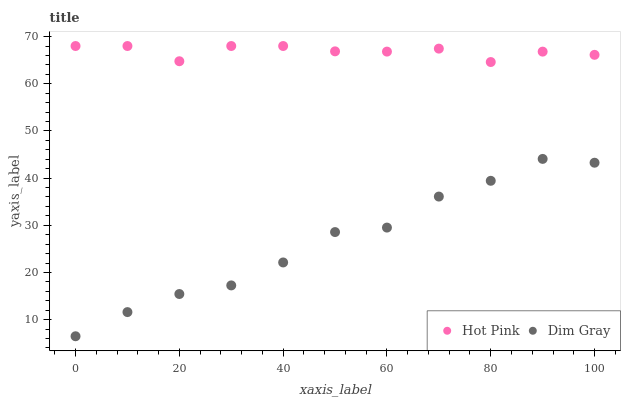Does Dim Gray have the minimum area under the curve?
Answer yes or no. Yes. Does Hot Pink have the maximum area under the curve?
Answer yes or no. Yes. Does Hot Pink have the minimum area under the curve?
Answer yes or no. No. Is Hot Pink the smoothest?
Answer yes or no. Yes. Is Dim Gray the roughest?
Answer yes or no. Yes. Is Hot Pink the roughest?
Answer yes or no. No. Does Dim Gray have the lowest value?
Answer yes or no. Yes. Does Hot Pink have the lowest value?
Answer yes or no. No. Does Hot Pink have the highest value?
Answer yes or no. Yes. Is Dim Gray less than Hot Pink?
Answer yes or no. Yes. Is Hot Pink greater than Dim Gray?
Answer yes or no. Yes. Does Dim Gray intersect Hot Pink?
Answer yes or no. No. 